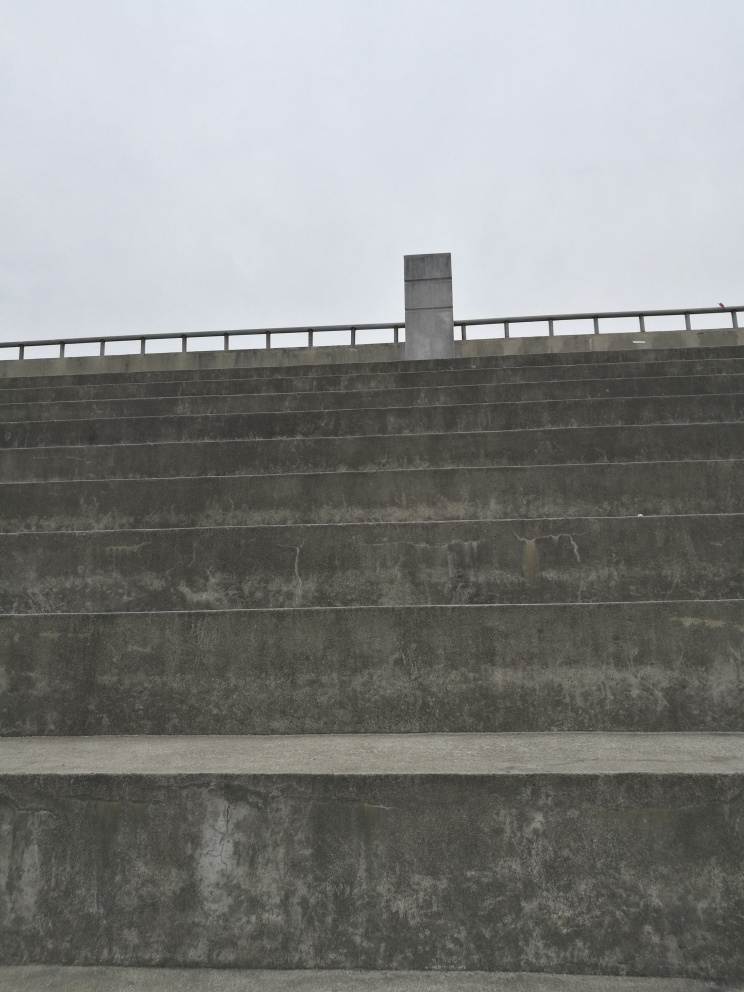If you had to describe the mood or atmosphere this image conveys, what would it be? The image conveys a mood of solemnity and stillness, which is accentuated by the overcast sky and the monolithic appearance of the concrete structure. There's a certain minimalistic beauty to it, evoking feelings of isolation and introspection. 